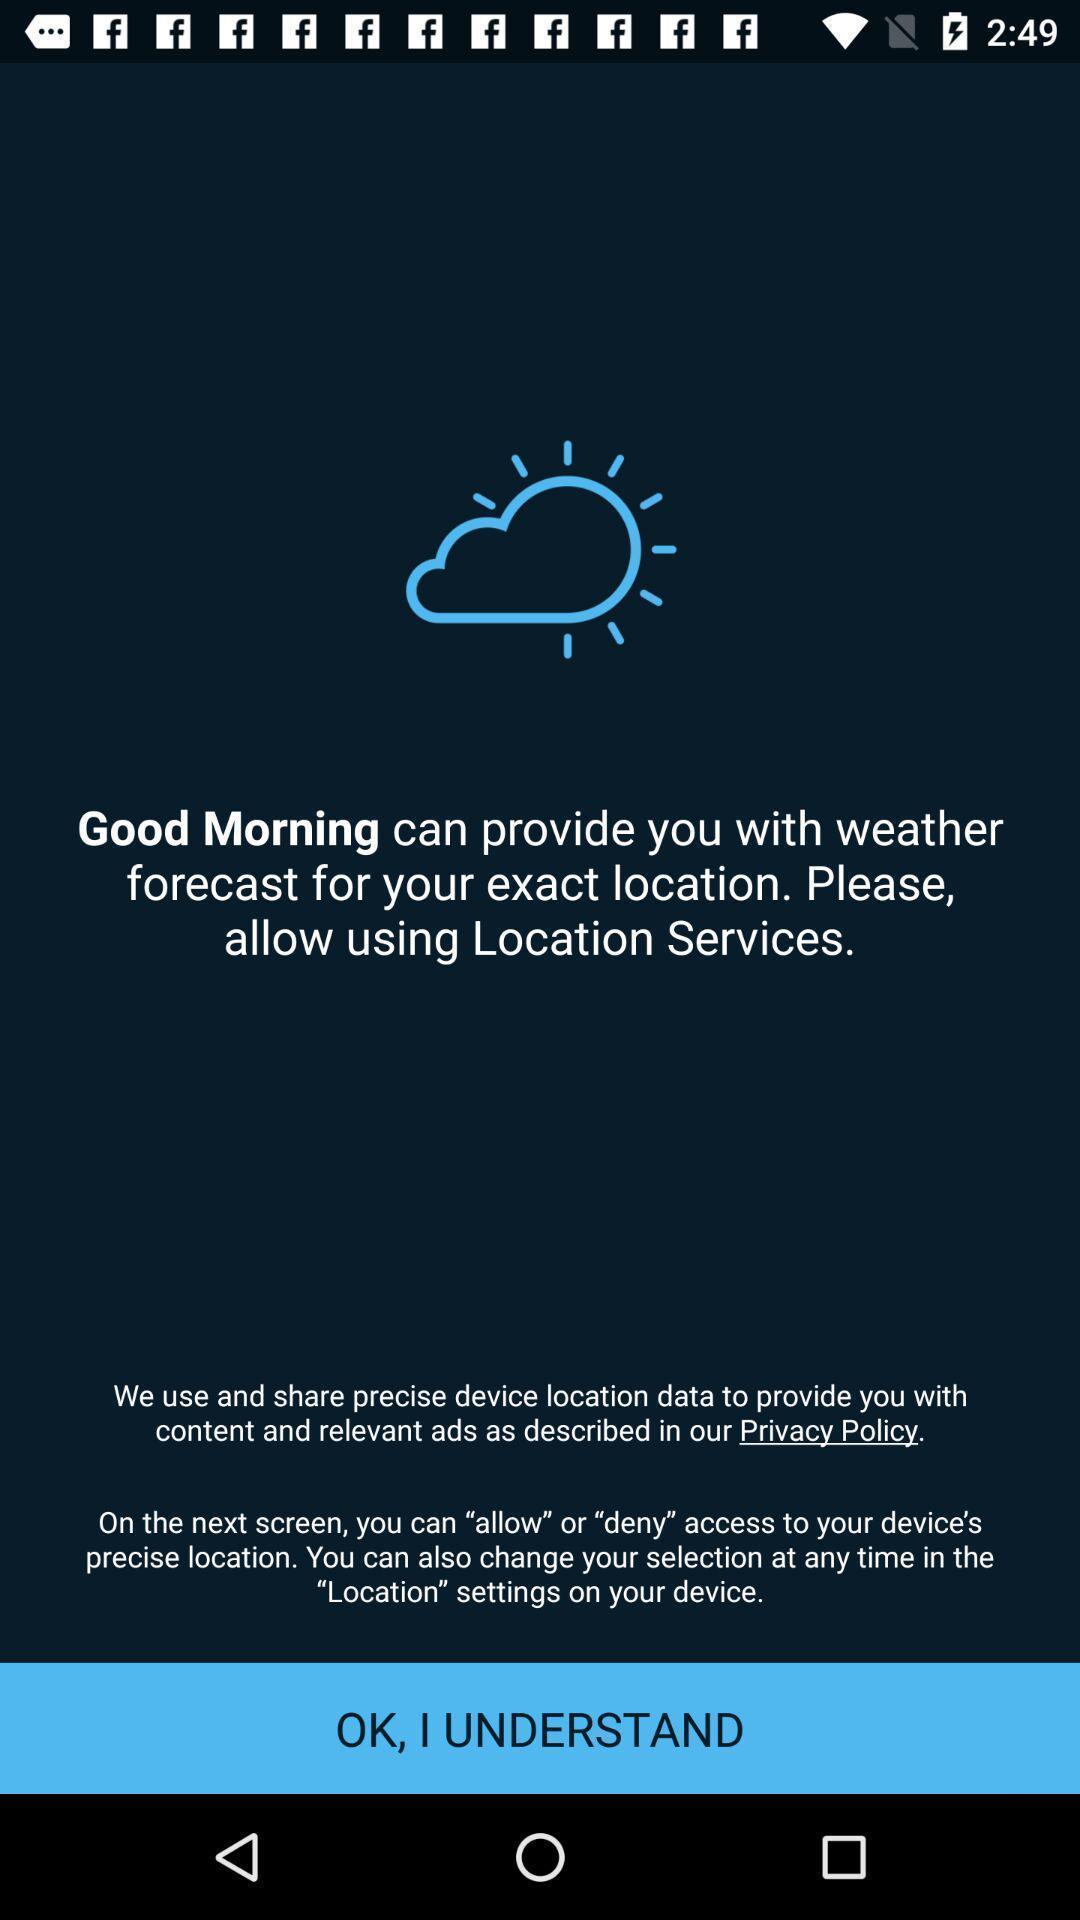What is the overall content of this screenshot? Start page of a sleep app. 